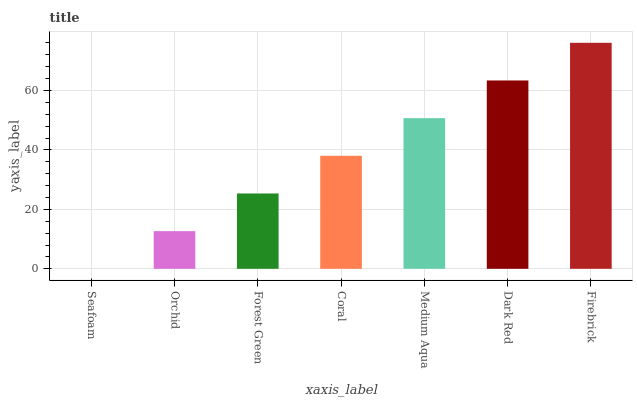Is Seafoam the minimum?
Answer yes or no. Yes. Is Firebrick the maximum?
Answer yes or no. Yes. Is Orchid the minimum?
Answer yes or no. No. Is Orchid the maximum?
Answer yes or no. No. Is Orchid greater than Seafoam?
Answer yes or no. Yes. Is Seafoam less than Orchid?
Answer yes or no. Yes. Is Seafoam greater than Orchid?
Answer yes or no. No. Is Orchid less than Seafoam?
Answer yes or no. No. Is Coral the high median?
Answer yes or no. Yes. Is Coral the low median?
Answer yes or no. Yes. Is Dark Red the high median?
Answer yes or no. No. Is Medium Aqua the low median?
Answer yes or no. No. 